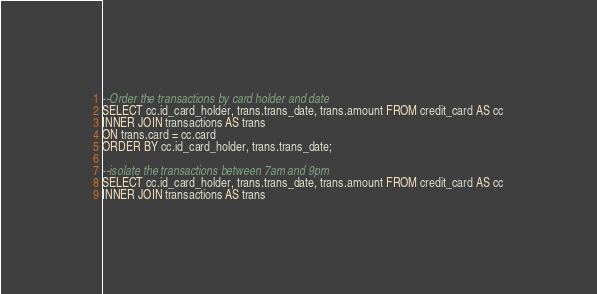Convert code to text. <code><loc_0><loc_0><loc_500><loc_500><_SQL_>--Order the transactions by card holder and date
SELECT cc.id_card_holder, trans.trans_date, trans.amount FROM credit_card AS cc
INNER JOIN transactions AS trans
ON trans.card = cc.card
ORDER BY cc.id_card_holder, trans.trans_date;

--isolate the transactions between 7am and 9pm
SELECT cc.id_card_holder, trans.trans_date, trans.amount FROM credit_card AS cc
INNER JOIN transactions AS trans</code> 